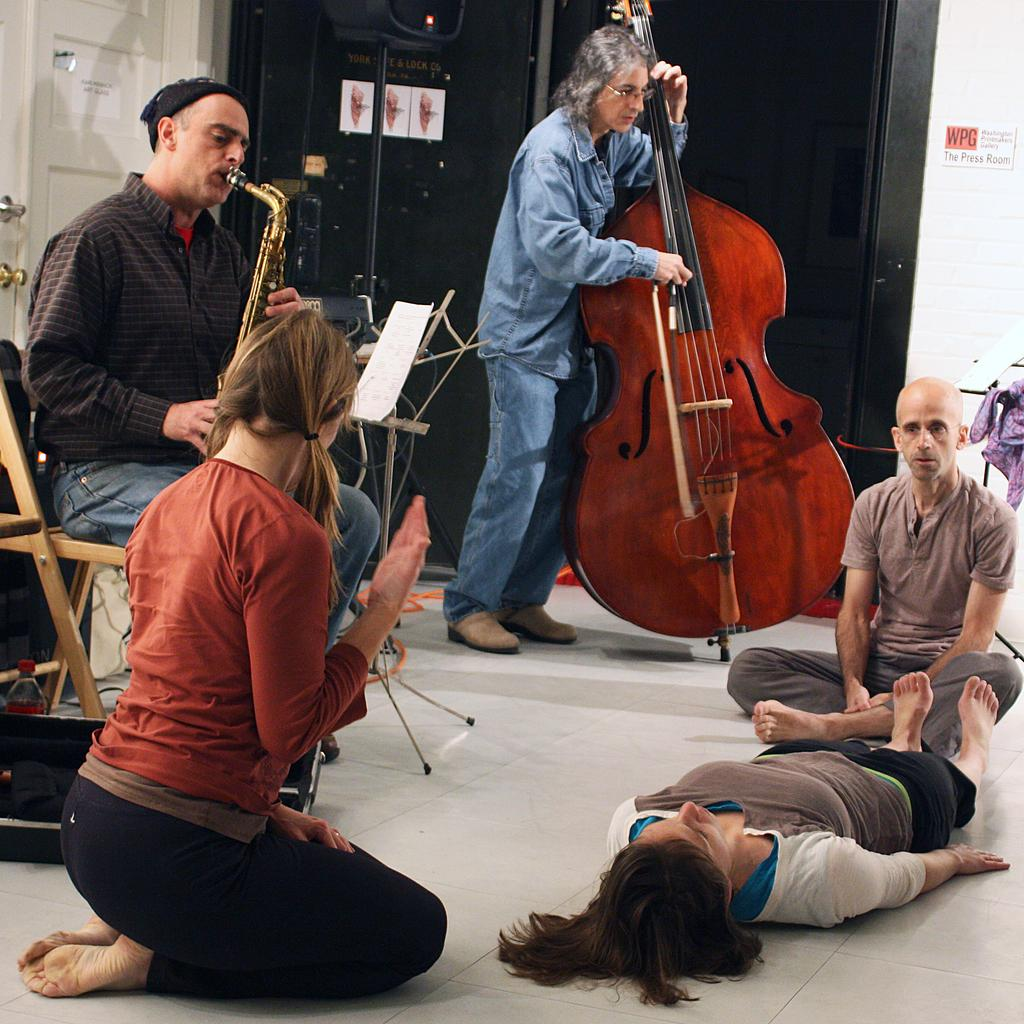What are the two people in the image doing? The two people in the image are playing musical instruments. How many people are in front of the musicians? There are three people in front of the musicians. What are the positions of the people in front? Two of the people in front are sitting. What is the position of the woman in the image? A woman is lying on the floor. What type of cattle can be seen in the scene? There is no cattle present in the image; it features two musicians and people in front of them. How many people are slipping in the scene? There is no indication of anyone slipping in the image. 